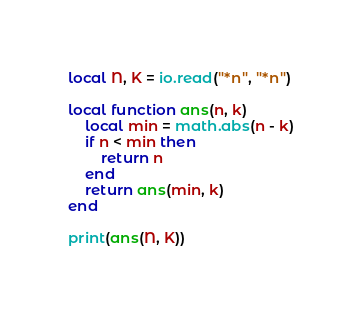<code> <loc_0><loc_0><loc_500><loc_500><_Lua_>local N, K = io.read("*n", "*n")

local function ans(n, k)
    local min = math.abs(n - k)
    if n < min then
        return n
    end
    return ans(min, k)
end

print(ans(N, K))</code> 